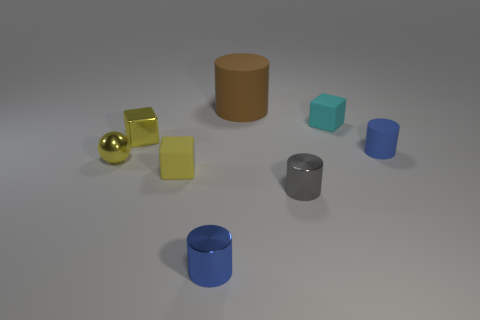The brown object is what size?
Your answer should be very brief. Large. There is a tiny metal ball; is it the same color as the small metal object that is to the right of the brown object?
Your response must be concise. No. What is the color of the metallic object right of the rubber thing behind the cyan rubber object?
Ensure brevity in your answer.  Gray. Is there anything else that has the same size as the brown cylinder?
Your answer should be very brief. No. Do the small blue thing that is in front of the small sphere and the gray metallic thing have the same shape?
Your answer should be very brief. Yes. How many tiny objects are to the right of the tiny gray thing and in front of the tiny yellow rubber cube?
Offer a terse response. 0. What is the color of the shiny thing right of the tiny blue object in front of the tiny blue object that is right of the cyan rubber object?
Ensure brevity in your answer.  Gray. There is a shiny cylinder that is in front of the tiny gray shiny cylinder; how many gray metal cylinders are left of it?
Your answer should be very brief. 0. How many other things are the same shape as the big matte thing?
Make the answer very short. 3. How many things are small blue matte cylinders or small blue things on the left side of the cyan object?
Your answer should be very brief. 2. 